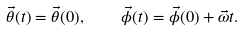Convert formula to latex. <formula><loc_0><loc_0><loc_500><loc_500>\vec { \theta } ( t ) = \vec { \theta } ( 0 ) , \quad \vec { \phi } ( t ) = \vec { \phi } ( 0 ) + \vec { \omega } t .</formula> 